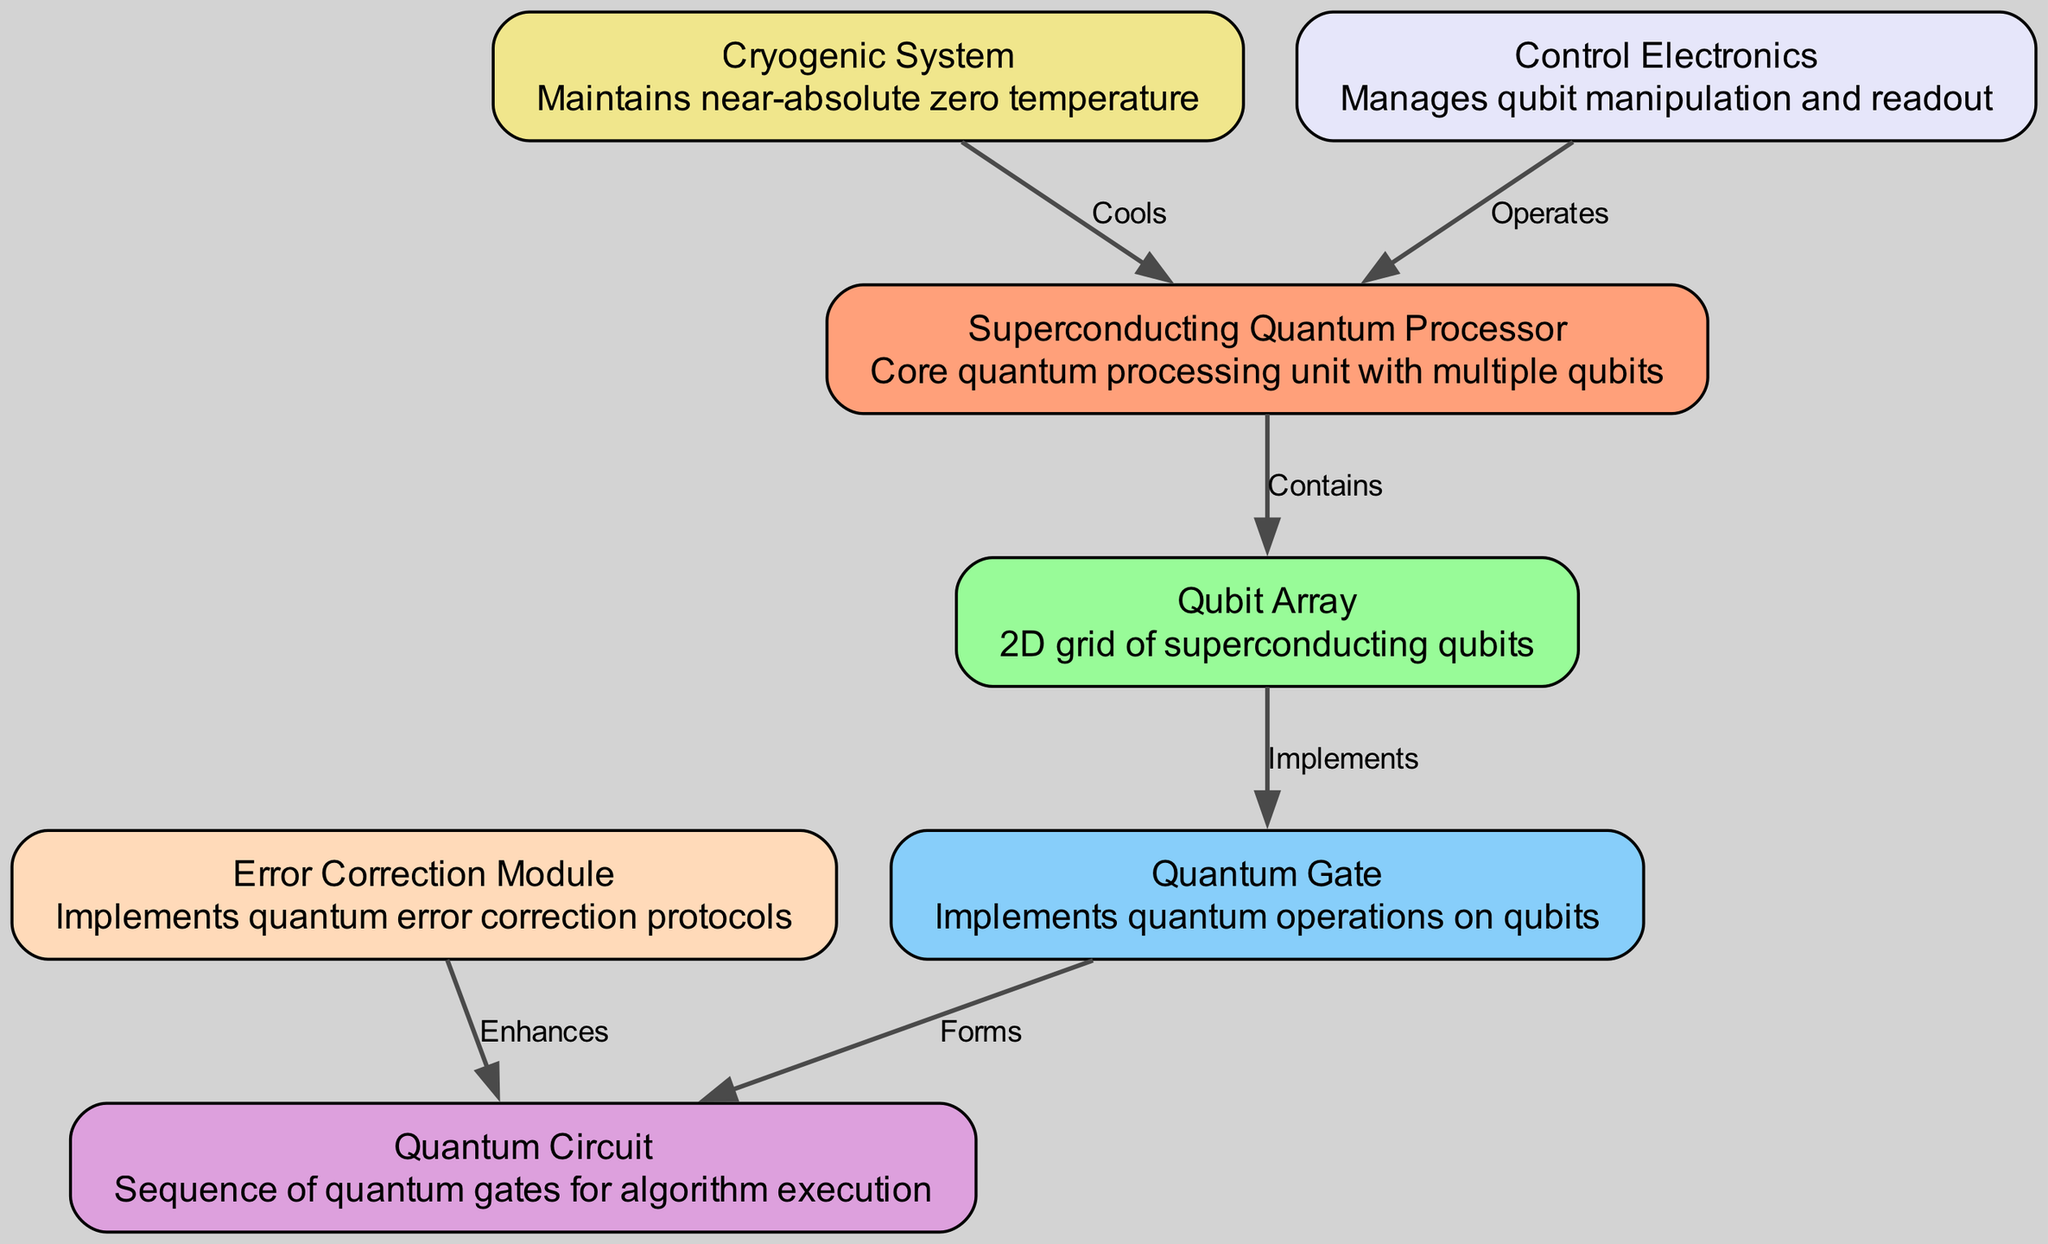What is the name of the core quantum processing unit? The diagram identifies the core quantum processing unit as the "Superconducting Quantum Processor," which is crucial for quantum operations and contains multiple qubits.
Answer: Superconducting Quantum Processor How many nodes are present in the diagram? The diagram includes 7 distinct nodes, each representing a key component of the quantum computing system, such as the qubit array and the cryogenic system.
Answer: 7 Which component implements quantum operations on qubits? According to the diagram, the "Quantum Gate" is responsible for implementing quantum operations, as it directly connects to the qubit array to perform necessary functions.
Answer: Quantum Gate What does the Cryogenic System do? The diagram specifies that the "Cryogenic System" cools the core quantum processing unit, thereby ensuring that it operates at near-absolute zero temperatures, which is essential for maintaining quantum coherence.
Answer: Cools What is the relationship between the Quantum Gate and the Quantum Circuit? The relationship is depicted as "Forms," indicating that the Quantum Gate contributes to the construction of the Quantum Circuit, which is a sequence of these gates used for executing quantum algorithms.
Answer: Forms How is quantum error correction enhanced in the system? The diagram shows that the "Error Correction Module" enhances the Quantum Circuit, which implies that it adds layers of error correction protocols to improve the reliability of quantum computations performed by the circuit.
Answer: Enhances Which node contains a 2D grid of superconducting qubits? The diagram labels the "Qubit Array" as the node that contains a 2D grid, emphasizing its arrangement and role in housing the qubits necessary for quantum computation.
Answer: Qubit Array What manages the manipulation and readout of qubits? The "Control Electronics" is identified in the diagram as the component that manages the manipulation and readout processes of qubits, ensuring precise control over their states during operation.
Answer: Control Electronics Which node enhances the performance of quantum operations through error correction? The "Error Correction Module" is illustrated to enhance the Quantum Circuit, pointing to its critical role in improving the accuracy of quantum operations by correcting errors that may arise during computation.
Answer: Error Correction Module 